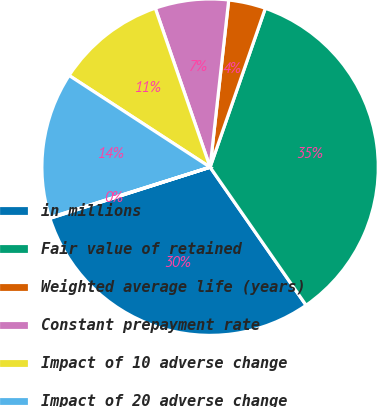<chart> <loc_0><loc_0><loc_500><loc_500><pie_chart><fcel>in millions<fcel>Fair value of retained<fcel>Weighted average life (years)<fcel>Constant prepayment rate<fcel>Impact of 10 adverse change<fcel>Impact of 20 adverse change<fcel>Discount rate<nl><fcel>29.75%<fcel>35.01%<fcel>3.56%<fcel>7.05%<fcel>10.54%<fcel>14.04%<fcel>0.06%<nl></chart> 